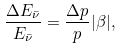Convert formula to latex. <formula><loc_0><loc_0><loc_500><loc_500>\frac { \Delta E _ { \bar { \nu } } } { E _ { \bar { \nu } } } = \frac { \Delta p } { p } | \beta | ,</formula> 